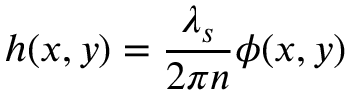<formula> <loc_0><loc_0><loc_500><loc_500>h ( x , y ) = \frac { { \lambda } _ { s } } { 2 { \pi } n } { \phi } ( x , y )</formula> 